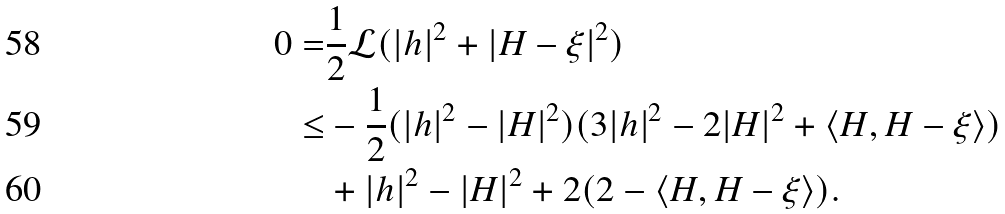Convert formula to latex. <formula><loc_0><loc_0><loc_500><loc_500>0 = & \frac { 1 } { 2 } \mathcal { L } ( | h | ^ { 2 } + | H - \xi | ^ { 2 } ) \\ \leq & - \frac { 1 } { 2 } ( | h | ^ { 2 } - | H | ^ { 2 } ) ( 3 | h | ^ { 2 } - 2 | H | ^ { 2 } + \langle H , H - \xi \rangle ) \\ & + | h | ^ { 2 } - | H | ^ { 2 } + 2 ( 2 - \langle H , H - \xi \rangle ) .</formula> 